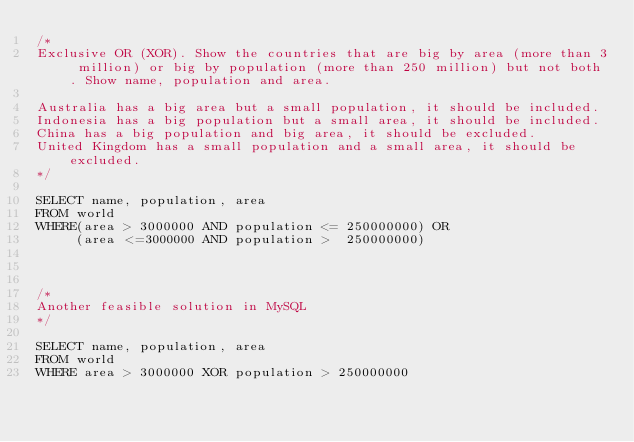Convert code to text. <code><loc_0><loc_0><loc_500><loc_500><_SQL_>/*
Exclusive OR (XOR). Show the countries that are big by area (more than 3 million) or big by population (more than 250 million) but not both. Show name, population and area.

Australia has a big area but a small population, it should be included.
Indonesia has a big population but a small area, it should be included.
China has a big population and big area, it should be excluded.
United Kingdom has a small population and a small area, it should be excluded.
*/

SELECT name, population, area
FROM world
WHERE(area > 3000000 AND population <= 250000000) OR
     (area <=3000000 AND population >  250000000)



/*
Another feasible solution in MySQL
*/

SELECT name, population, area
FROM world
WHERE area > 3000000 XOR population > 250000000</code> 